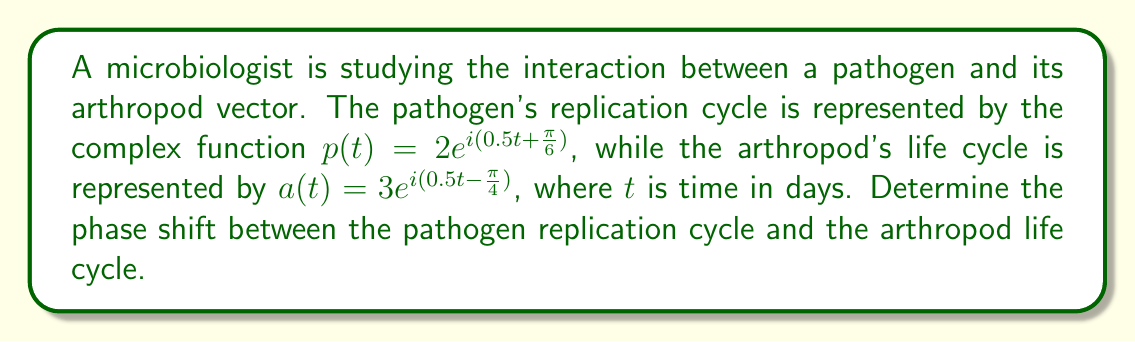Provide a solution to this math problem. To find the phase shift between the two cycles, we need to compare the arguments of the complex exponentials:

1) For the pathogen: $p(t) = 2e^{i(0.5t + \frac{\pi}{6})}$
   The argument is $0.5t + \frac{\pi}{6}$

2) For the arthropod: $a(t) = 3e^{i(0.5t - \frac{\pi}{4})}$
   The argument is $0.5t - \frac{\pi}{4}$

3) The phase shift is the difference between these arguments:
   $$(0.5t + \frac{\pi}{6}) - (0.5t - \frac{\pi}{4}) = \frac{\pi}{6} + \frac{\pi}{4} = \frac{\pi}{6} + \frac{3\pi}{12} = \frac{2\pi}{12} + \frac{3\pi}{12} = \frac{5\pi}{12}$$

4) To convert this to radians, we can leave it as is: $\frac{5\pi}{12}$ radians

5) To convert to degrees, we multiply by $\frac{180°}{\pi}$:
   $$\frac{5\pi}{12} \cdot \frac{180°}{\pi} = 75°$$

Therefore, the phase shift is $\frac{5\pi}{12}$ radians or 75°.
Answer: $\frac{5\pi}{12}$ radians or 75° 